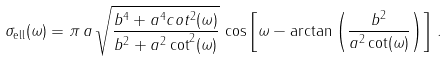Convert formula to latex. <formula><loc_0><loc_0><loc_500><loc_500>\sigma _ { \text {ell} } ( \omega ) = \pi \, a \, \sqrt { \frac { b ^ { 4 } + a ^ { 4 } c o t ^ { 2 } ( \omega ) } { b ^ { 2 } + a ^ { 2 } \cot ^ { 2 } ( \omega ) } } \, \cos \left [ \omega - \arctan \left ( \frac { b ^ { 2 } } { a ^ { 2 } \cot ( \omega ) } \right ) \right ] \, .</formula> 